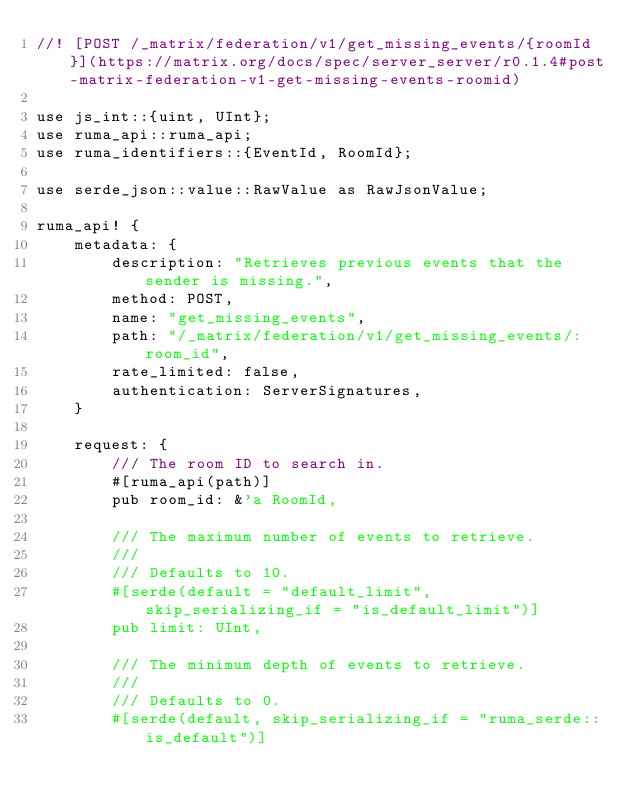<code> <loc_0><loc_0><loc_500><loc_500><_Rust_>//! [POST /_matrix/federation/v1/get_missing_events/{roomId}](https://matrix.org/docs/spec/server_server/r0.1.4#post-matrix-federation-v1-get-missing-events-roomid)

use js_int::{uint, UInt};
use ruma_api::ruma_api;
use ruma_identifiers::{EventId, RoomId};

use serde_json::value::RawValue as RawJsonValue;

ruma_api! {
    metadata: {
        description: "Retrieves previous events that the sender is missing.",
        method: POST,
        name: "get_missing_events",
        path: "/_matrix/federation/v1/get_missing_events/:room_id",
        rate_limited: false,
        authentication: ServerSignatures,
    }

    request: {
        /// The room ID to search in.
        #[ruma_api(path)]
        pub room_id: &'a RoomId,

        /// The maximum number of events to retrieve.
        ///
        /// Defaults to 10.
        #[serde(default = "default_limit", skip_serializing_if = "is_default_limit")]
        pub limit: UInt,

        /// The minimum depth of events to retrieve.
        ///
        /// Defaults to 0.
        #[serde(default, skip_serializing_if = "ruma_serde::is_default")]</code> 